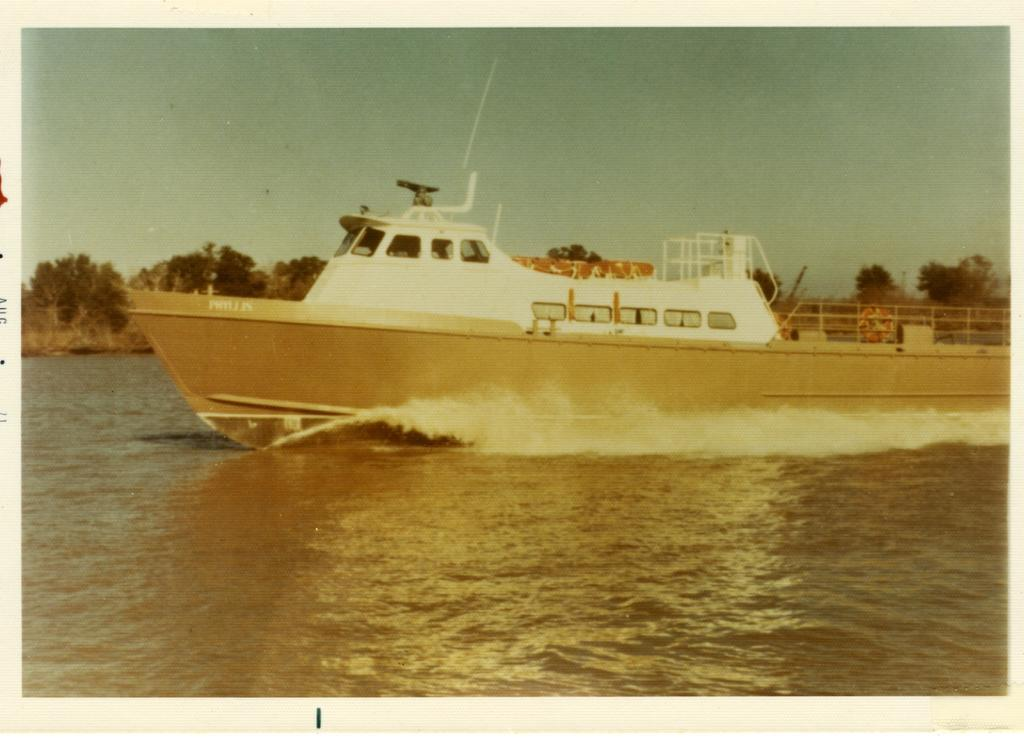What is the main subject of the image? The main subject of the image is a ship. Can you describe the ship's position in relation to the water? The ship is above the water in the image. What can be seen in the background of the image? There are trees and the sky visible in the background of the image. What type of seed is being planted by the air in the image? There is no seed or planting activity present in the image; it features a ship above the water with trees and the sky in the background. 